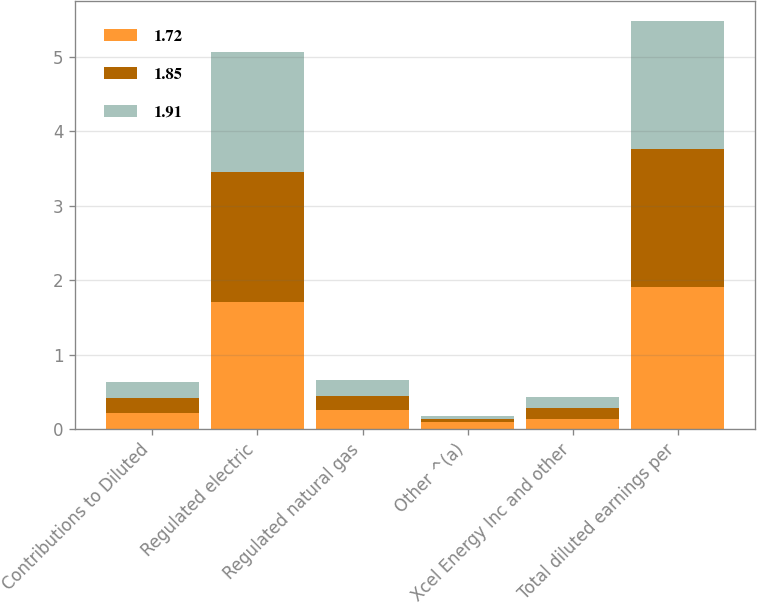<chart> <loc_0><loc_0><loc_500><loc_500><stacked_bar_chart><ecel><fcel>Contributions to Diluted<fcel>Regulated electric<fcel>Regulated natural gas<fcel>Other ^(a)<fcel>Xcel Energy Inc and other<fcel>Total diluted earnings per<nl><fcel>1.72<fcel>0.21<fcel>1.71<fcel>0.25<fcel>0.09<fcel>0.14<fcel>1.91<nl><fcel>1.85<fcel>0.21<fcel>1.74<fcel>0.2<fcel>0.05<fcel>0.14<fcel>1.85<nl><fcel>1.91<fcel>0.21<fcel>1.62<fcel>0.21<fcel>0.04<fcel>0.15<fcel>1.72<nl></chart> 